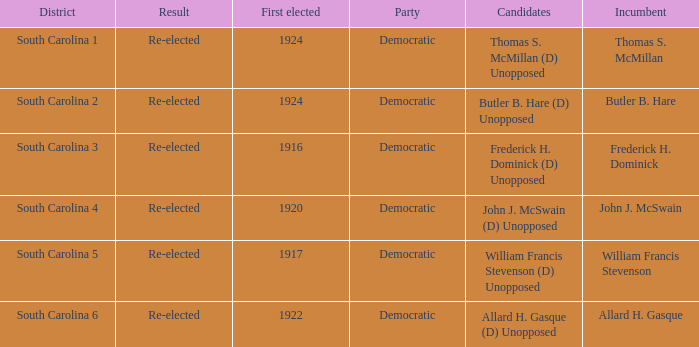What is the result for south carolina 4? Re-elected. 